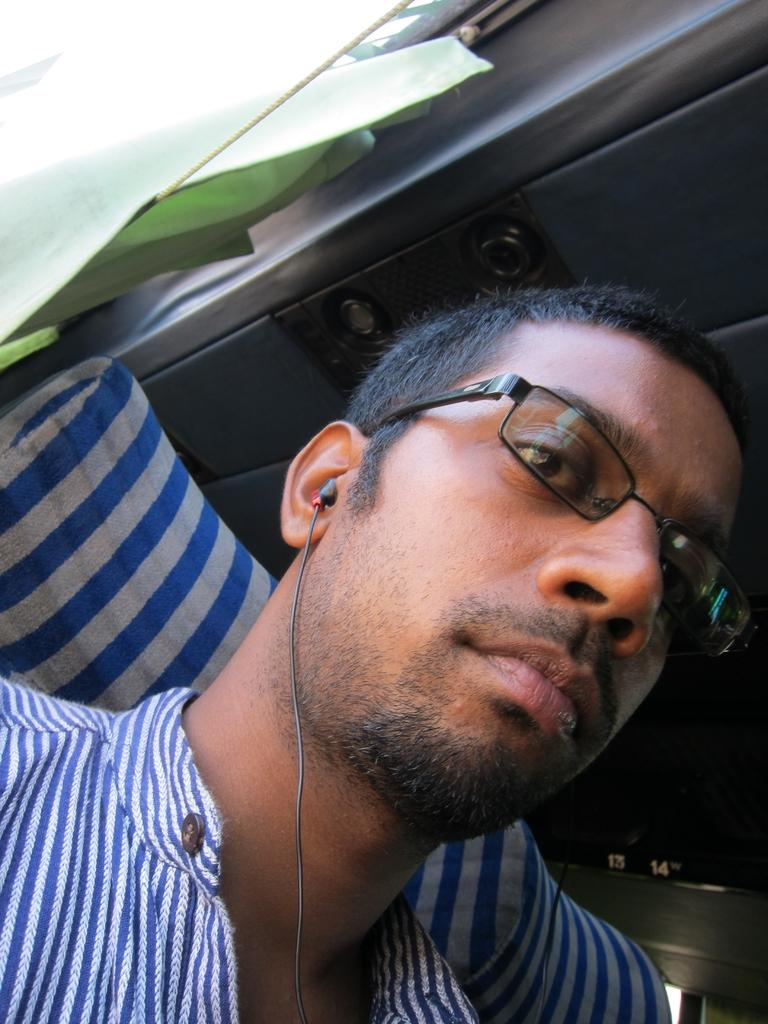What is the main subject of the image? There is a man in the image. Can you describe the man's clothing? The man is wearing a blue and white t-shirt. What accessories is the man wearing? The man is wearing specs and earphones. What can be seen in the background of the image? There is a green curtain in the background of the image. What type of toothpaste is the man using in the image? There is no toothpaste present in the image. Can you see any animals from the zoo in the image? There are no animals from the zoo visible in the image. 